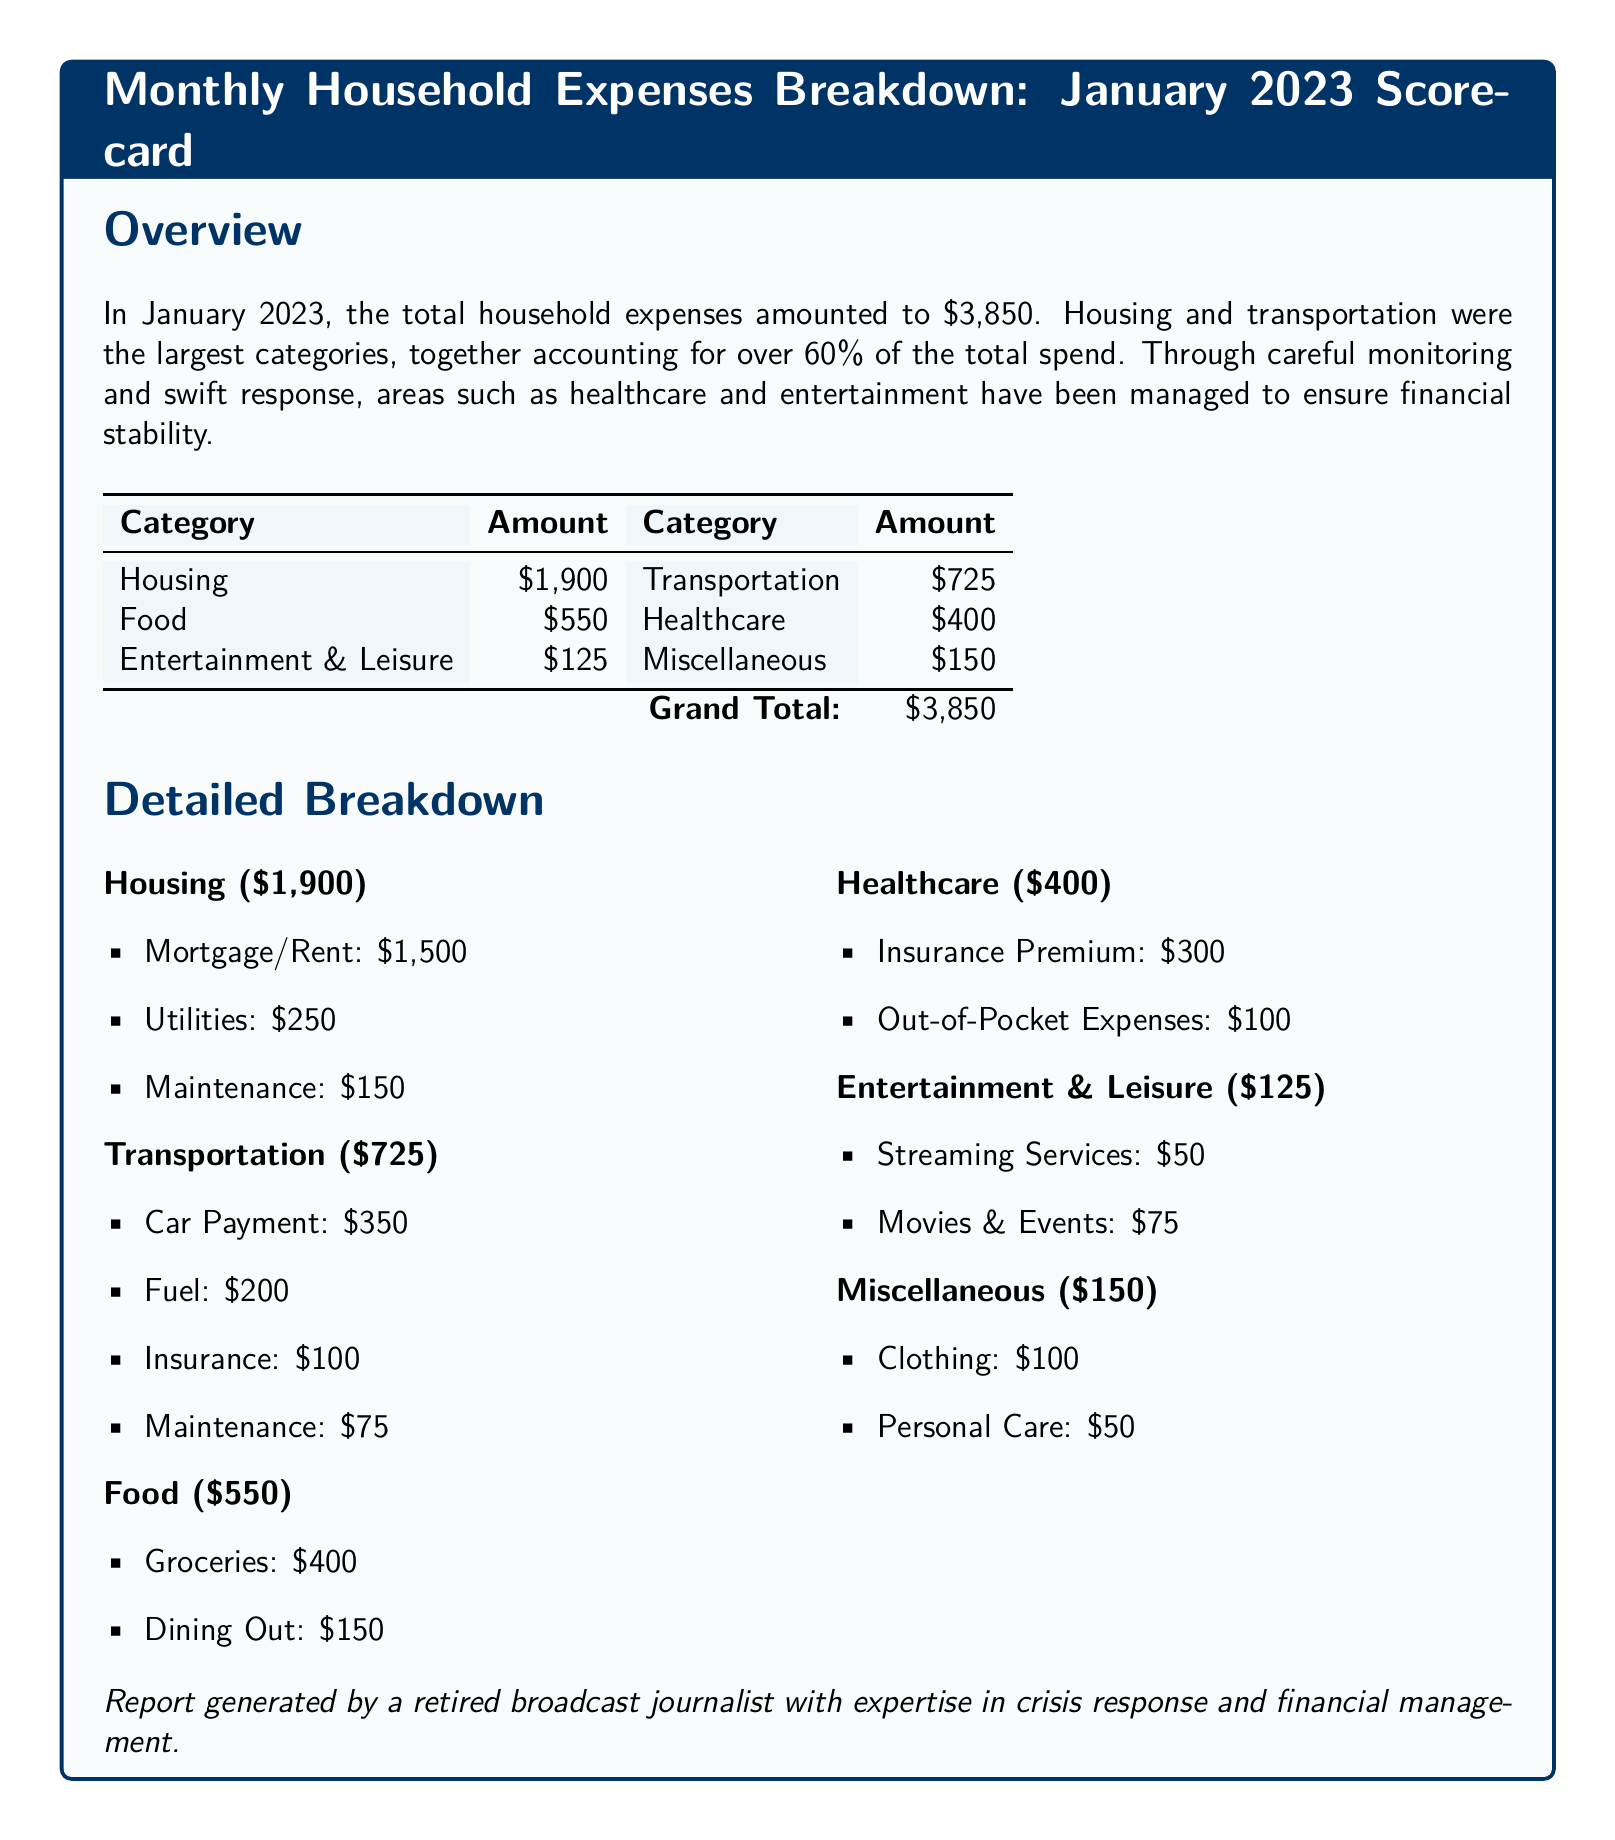What was the total amount of household expenses in January 2023? The total household expenses are stated in the overview section as $3,850.
Answer: $3,850 What percentage of the total expenses did housing and transportation account for? The document states that housing and transportation account for over 60% of the total expenses.
Answer: Over 60% How much was spent on food? The amount spent on food is clearly listed in the table as $550.
Answer: $550 What is the amount allocated for healthcare? The amount designated for healthcare is detailed in the breakdown section as $400.
Answer: $400 Which category has the lowest expenditure? The expense categories show that entertainment and leisure is the lowest at $125.
Answer: $125 What is the total amount spent on transportation? The transportation expenses sum up to $725 as shown in the table.
Answer: $725 How much was spent on utilities within the housing category? The utilities expense in the housing section is specified as $250.
Answer: $250 What are the two main components of healthcare spending? The document lists insurance premium and out-of-pocket expenses as the components, amounting to $300 and $100 respectively.
Answer: Insurance Premium and Out-of-Pocket Expenses What amount is allocated for miscellaneous expenses? The miscellaneous category expense is shown as $150 in the breakdown.
Answer: $150 